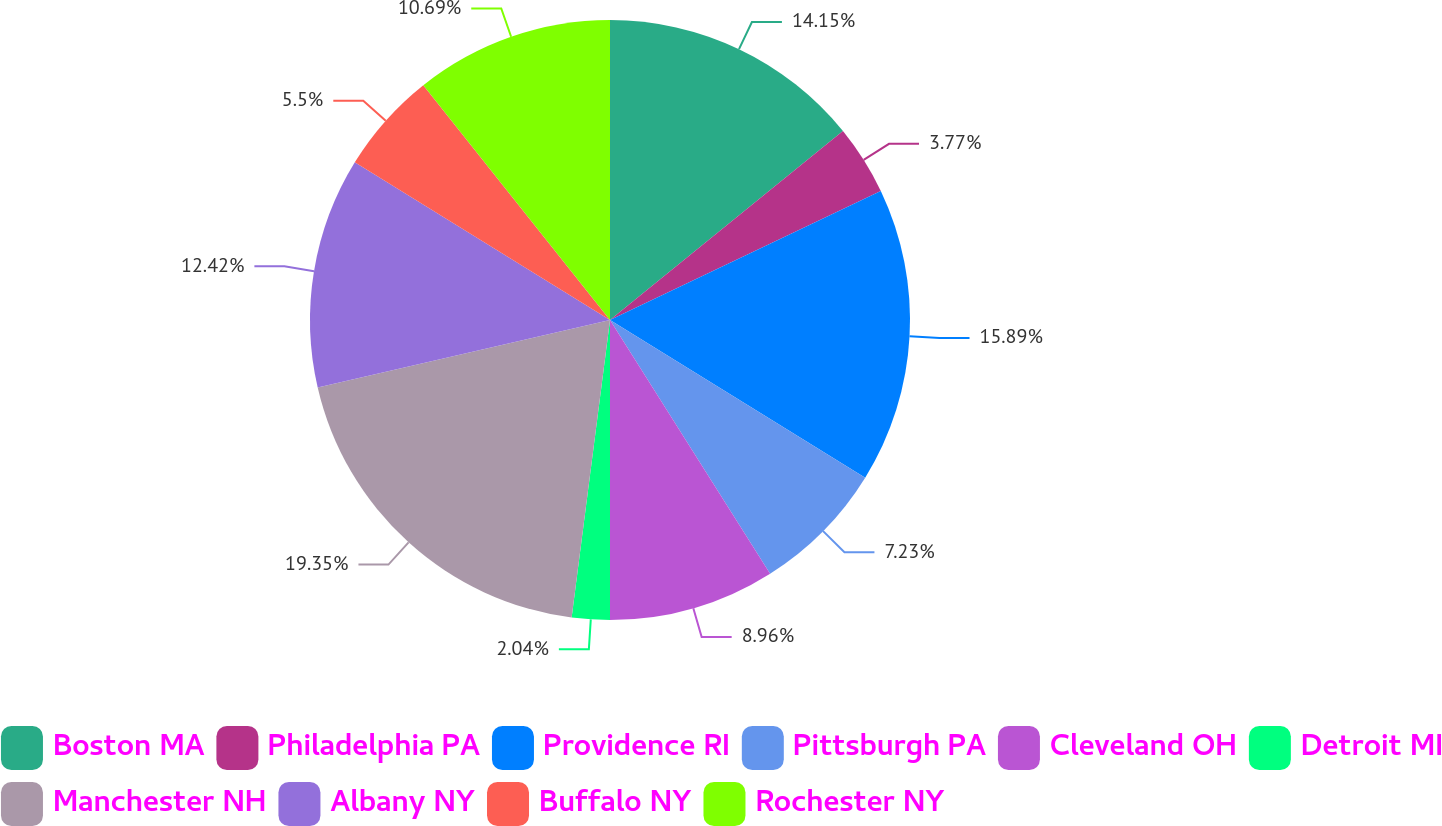<chart> <loc_0><loc_0><loc_500><loc_500><pie_chart><fcel>Boston MA<fcel>Philadelphia PA<fcel>Providence RI<fcel>Pittsburgh PA<fcel>Cleveland OH<fcel>Detroit MI<fcel>Manchester NH<fcel>Albany NY<fcel>Buffalo NY<fcel>Rochester NY<nl><fcel>14.15%<fcel>3.77%<fcel>15.89%<fcel>7.23%<fcel>8.96%<fcel>2.04%<fcel>19.35%<fcel>12.42%<fcel>5.5%<fcel>10.69%<nl></chart> 